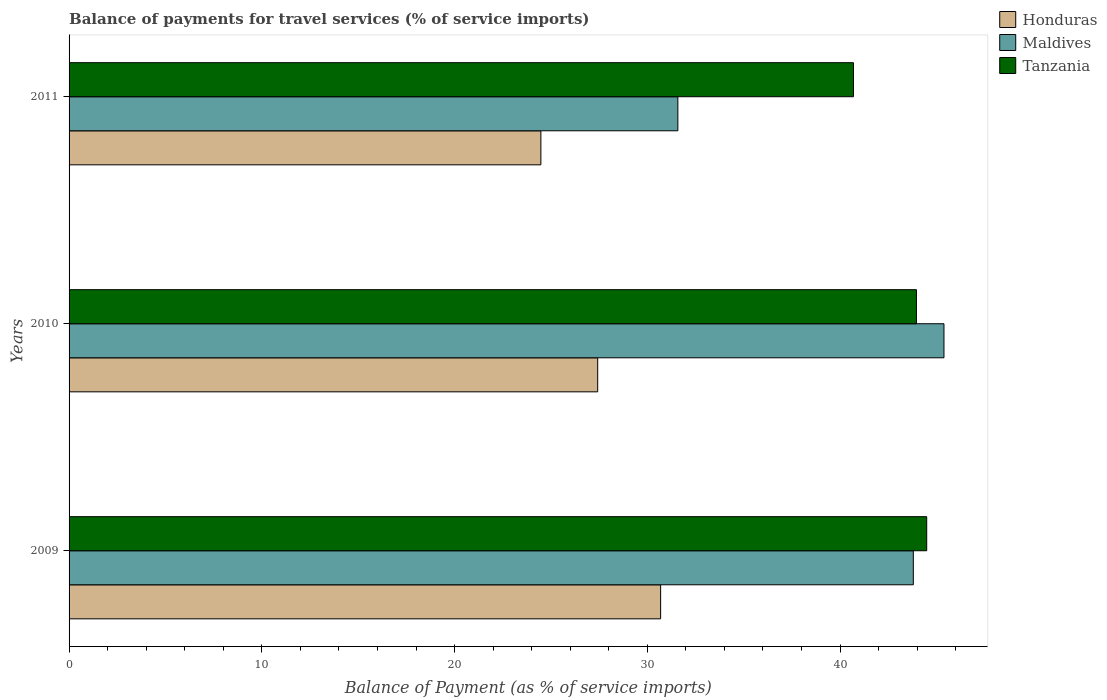How many different coloured bars are there?
Give a very brief answer. 3. How many bars are there on the 2nd tick from the top?
Your response must be concise. 3. How many bars are there on the 2nd tick from the bottom?
Your answer should be compact. 3. What is the balance of payments for travel services in Tanzania in 2011?
Offer a terse response. 40.7. Across all years, what is the maximum balance of payments for travel services in Tanzania?
Provide a short and direct response. 44.5. Across all years, what is the minimum balance of payments for travel services in Honduras?
Ensure brevity in your answer.  24.48. What is the total balance of payments for travel services in Maldives in the graph?
Offer a very short reply. 120.78. What is the difference between the balance of payments for travel services in Tanzania in 2009 and that in 2011?
Your answer should be very brief. 3.8. What is the difference between the balance of payments for travel services in Tanzania in 2010 and the balance of payments for travel services in Honduras in 2011?
Provide a succinct answer. 19.49. What is the average balance of payments for travel services in Maldives per year?
Make the answer very short. 40.26. In the year 2011, what is the difference between the balance of payments for travel services in Maldives and balance of payments for travel services in Honduras?
Provide a succinct answer. 7.11. In how many years, is the balance of payments for travel services in Maldives greater than 8 %?
Give a very brief answer. 3. What is the ratio of the balance of payments for travel services in Honduras in 2009 to that in 2011?
Give a very brief answer. 1.25. What is the difference between the highest and the second highest balance of payments for travel services in Honduras?
Your answer should be very brief. 3.27. What is the difference between the highest and the lowest balance of payments for travel services in Maldives?
Ensure brevity in your answer.  13.81. In how many years, is the balance of payments for travel services in Maldives greater than the average balance of payments for travel services in Maldives taken over all years?
Your response must be concise. 2. What does the 1st bar from the top in 2009 represents?
Make the answer very short. Tanzania. What does the 1st bar from the bottom in 2010 represents?
Your response must be concise. Honduras. Are all the bars in the graph horizontal?
Your answer should be compact. Yes. How many years are there in the graph?
Your answer should be compact. 3. Are the values on the major ticks of X-axis written in scientific E-notation?
Provide a succinct answer. No. Does the graph contain grids?
Your response must be concise. No. Where does the legend appear in the graph?
Your answer should be very brief. Top right. How many legend labels are there?
Ensure brevity in your answer.  3. How are the legend labels stacked?
Give a very brief answer. Vertical. What is the title of the graph?
Your answer should be very brief. Balance of payments for travel services (% of service imports). Does "Belize" appear as one of the legend labels in the graph?
Your response must be concise. No. What is the label or title of the X-axis?
Offer a terse response. Balance of Payment (as % of service imports). What is the label or title of the Y-axis?
Give a very brief answer. Years. What is the Balance of Payment (as % of service imports) of Honduras in 2009?
Give a very brief answer. 30.69. What is the Balance of Payment (as % of service imports) in Maldives in 2009?
Your response must be concise. 43.8. What is the Balance of Payment (as % of service imports) in Tanzania in 2009?
Offer a terse response. 44.5. What is the Balance of Payment (as % of service imports) in Honduras in 2010?
Your answer should be compact. 27.43. What is the Balance of Payment (as % of service imports) in Maldives in 2010?
Make the answer very short. 45.39. What is the Balance of Payment (as % of service imports) of Tanzania in 2010?
Your response must be concise. 43.96. What is the Balance of Payment (as % of service imports) of Honduras in 2011?
Keep it short and to the point. 24.48. What is the Balance of Payment (as % of service imports) in Maldives in 2011?
Give a very brief answer. 31.59. What is the Balance of Payment (as % of service imports) in Tanzania in 2011?
Keep it short and to the point. 40.7. Across all years, what is the maximum Balance of Payment (as % of service imports) in Honduras?
Your answer should be very brief. 30.69. Across all years, what is the maximum Balance of Payment (as % of service imports) in Maldives?
Offer a terse response. 45.39. Across all years, what is the maximum Balance of Payment (as % of service imports) in Tanzania?
Make the answer very short. 44.5. Across all years, what is the minimum Balance of Payment (as % of service imports) of Honduras?
Offer a terse response. 24.48. Across all years, what is the minimum Balance of Payment (as % of service imports) in Maldives?
Your answer should be compact. 31.59. Across all years, what is the minimum Balance of Payment (as % of service imports) in Tanzania?
Provide a succinct answer. 40.7. What is the total Balance of Payment (as % of service imports) in Honduras in the graph?
Provide a succinct answer. 82.6. What is the total Balance of Payment (as % of service imports) in Maldives in the graph?
Provide a succinct answer. 120.78. What is the total Balance of Payment (as % of service imports) of Tanzania in the graph?
Ensure brevity in your answer.  129.16. What is the difference between the Balance of Payment (as % of service imports) in Honduras in 2009 and that in 2010?
Offer a terse response. 3.27. What is the difference between the Balance of Payment (as % of service imports) in Maldives in 2009 and that in 2010?
Provide a succinct answer. -1.59. What is the difference between the Balance of Payment (as % of service imports) in Tanzania in 2009 and that in 2010?
Offer a very short reply. 0.53. What is the difference between the Balance of Payment (as % of service imports) of Honduras in 2009 and that in 2011?
Your answer should be compact. 6.21. What is the difference between the Balance of Payment (as % of service imports) in Maldives in 2009 and that in 2011?
Offer a very short reply. 12.22. What is the difference between the Balance of Payment (as % of service imports) of Tanzania in 2009 and that in 2011?
Provide a short and direct response. 3.8. What is the difference between the Balance of Payment (as % of service imports) of Honduras in 2010 and that in 2011?
Provide a succinct answer. 2.95. What is the difference between the Balance of Payment (as % of service imports) of Maldives in 2010 and that in 2011?
Your answer should be compact. 13.81. What is the difference between the Balance of Payment (as % of service imports) in Tanzania in 2010 and that in 2011?
Offer a very short reply. 3.27. What is the difference between the Balance of Payment (as % of service imports) of Honduras in 2009 and the Balance of Payment (as % of service imports) of Maldives in 2010?
Give a very brief answer. -14.7. What is the difference between the Balance of Payment (as % of service imports) in Honduras in 2009 and the Balance of Payment (as % of service imports) in Tanzania in 2010?
Offer a terse response. -13.27. What is the difference between the Balance of Payment (as % of service imports) of Maldives in 2009 and the Balance of Payment (as % of service imports) of Tanzania in 2010?
Give a very brief answer. -0.16. What is the difference between the Balance of Payment (as % of service imports) of Honduras in 2009 and the Balance of Payment (as % of service imports) of Maldives in 2011?
Your answer should be very brief. -0.89. What is the difference between the Balance of Payment (as % of service imports) in Honduras in 2009 and the Balance of Payment (as % of service imports) in Tanzania in 2011?
Provide a succinct answer. -10. What is the difference between the Balance of Payment (as % of service imports) in Maldives in 2009 and the Balance of Payment (as % of service imports) in Tanzania in 2011?
Offer a very short reply. 3.11. What is the difference between the Balance of Payment (as % of service imports) in Honduras in 2010 and the Balance of Payment (as % of service imports) in Maldives in 2011?
Your response must be concise. -4.16. What is the difference between the Balance of Payment (as % of service imports) of Honduras in 2010 and the Balance of Payment (as % of service imports) of Tanzania in 2011?
Provide a succinct answer. -13.27. What is the difference between the Balance of Payment (as % of service imports) in Maldives in 2010 and the Balance of Payment (as % of service imports) in Tanzania in 2011?
Offer a very short reply. 4.7. What is the average Balance of Payment (as % of service imports) in Honduras per year?
Make the answer very short. 27.53. What is the average Balance of Payment (as % of service imports) of Maldives per year?
Offer a very short reply. 40.26. What is the average Balance of Payment (as % of service imports) in Tanzania per year?
Offer a terse response. 43.05. In the year 2009, what is the difference between the Balance of Payment (as % of service imports) of Honduras and Balance of Payment (as % of service imports) of Maldives?
Your response must be concise. -13.11. In the year 2009, what is the difference between the Balance of Payment (as % of service imports) in Honduras and Balance of Payment (as % of service imports) in Tanzania?
Keep it short and to the point. -13.8. In the year 2009, what is the difference between the Balance of Payment (as % of service imports) in Maldives and Balance of Payment (as % of service imports) in Tanzania?
Your answer should be very brief. -0.69. In the year 2010, what is the difference between the Balance of Payment (as % of service imports) of Honduras and Balance of Payment (as % of service imports) of Maldives?
Your answer should be very brief. -17.97. In the year 2010, what is the difference between the Balance of Payment (as % of service imports) in Honduras and Balance of Payment (as % of service imports) in Tanzania?
Give a very brief answer. -16.54. In the year 2010, what is the difference between the Balance of Payment (as % of service imports) of Maldives and Balance of Payment (as % of service imports) of Tanzania?
Make the answer very short. 1.43. In the year 2011, what is the difference between the Balance of Payment (as % of service imports) in Honduras and Balance of Payment (as % of service imports) in Maldives?
Your answer should be compact. -7.11. In the year 2011, what is the difference between the Balance of Payment (as % of service imports) in Honduras and Balance of Payment (as % of service imports) in Tanzania?
Your answer should be very brief. -16.22. In the year 2011, what is the difference between the Balance of Payment (as % of service imports) of Maldives and Balance of Payment (as % of service imports) of Tanzania?
Offer a terse response. -9.11. What is the ratio of the Balance of Payment (as % of service imports) in Honduras in 2009 to that in 2010?
Your answer should be compact. 1.12. What is the ratio of the Balance of Payment (as % of service imports) in Maldives in 2009 to that in 2010?
Provide a succinct answer. 0.96. What is the ratio of the Balance of Payment (as % of service imports) of Tanzania in 2009 to that in 2010?
Make the answer very short. 1.01. What is the ratio of the Balance of Payment (as % of service imports) of Honduras in 2009 to that in 2011?
Offer a very short reply. 1.25. What is the ratio of the Balance of Payment (as % of service imports) in Maldives in 2009 to that in 2011?
Make the answer very short. 1.39. What is the ratio of the Balance of Payment (as % of service imports) in Tanzania in 2009 to that in 2011?
Give a very brief answer. 1.09. What is the ratio of the Balance of Payment (as % of service imports) in Honduras in 2010 to that in 2011?
Make the answer very short. 1.12. What is the ratio of the Balance of Payment (as % of service imports) in Maldives in 2010 to that in 2011?
Provide a short and direct response. 1.44. What is the ratio of the Balance of Payment (as % of service imports) of Tanzania in 2010 to that in 2011?
Provide a short and direct response. 1.08. What is the difference between the highest and the second highest Balance of Payment (as % of service imports) of Honduras?
Offer a terse response. 3.27. What is the difference between the highest and the second highest Balance of Payment (as % of service imports) in Maldives?
Provide a succinct answer. 1.59. What is the difference between the highest and the second highest Balance of Payment (as % of service imports) of Tanzania?
Provide a succinct answer. 0.53. What is the difference between the highest and the lowest Balance of Payment (as % of service imports) of Honduras?
Keep it short and to the point. 6.21. What is the difference between the highest and the lowest Balance of Payment (as % of service imports) of Maldives?
Your answer should be compact. 13.81. What is the difference between the highest and the lowest Balance of Payment (as % of service imports) in Tanzania?
Provide a short and direct response. 3.8. 